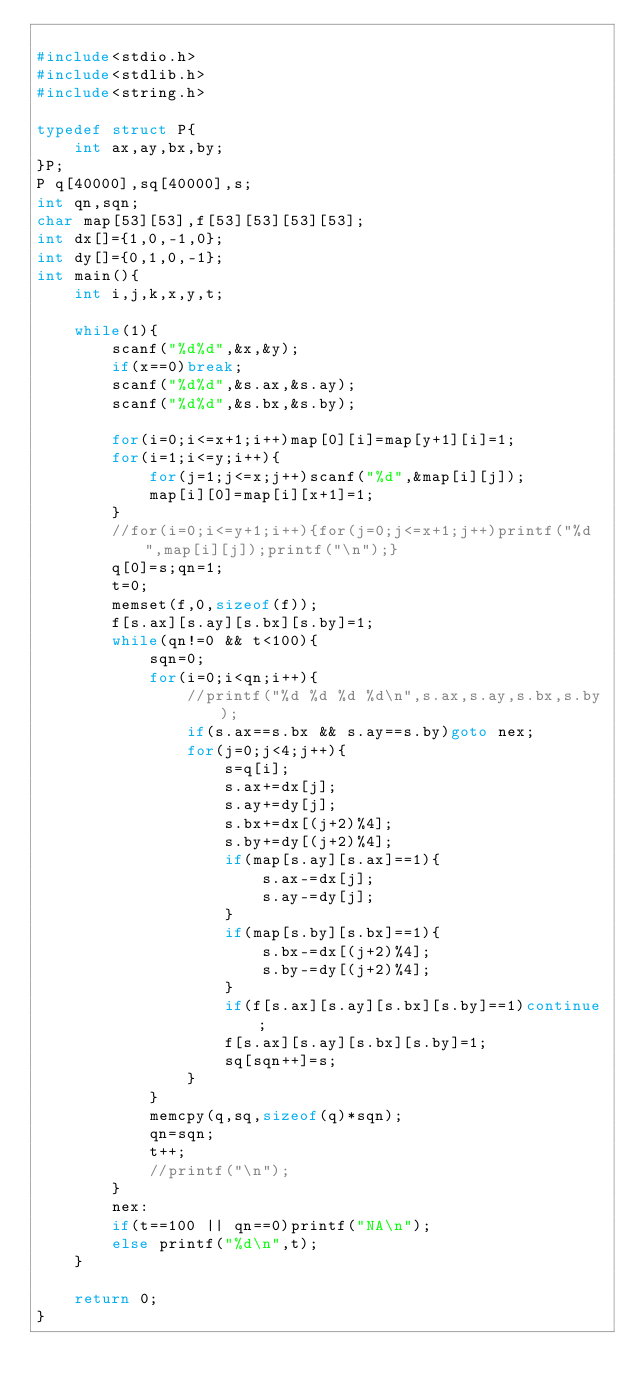Convert code to text. <code><loc_0><loc_0><loc_500><loc_500><_C_>
#include<stdio.h>
#include<stdlib.h>
#include<string.h>

typedef struct P{
	int ax,ay,bx,by;
}P;
P q[40000],sq[40000],s;
int qn,sqn;
char map[53][53],f[53][53][53][53];
int dx[]={1,0,-1,0};
int dy[]={0,1,0,-1};
int main(){
	int i,j,k,x,y,t;
	
	while(1){
		scanf("%d%d",&x,&y);
		if(x==0)break;
		scanf("%d%d",&s.ax,&s.ay);
		scanf("%d%d",&s.bx,&s.by);
		
		for(i=0;i<=x+1;i++)map[0][i]=map[y+1][i]=1;
		for(i=1;i<=y;i++){
			for(j=1;j<=x;j++)scanf("%d",&map[i][j]);
			map[i][0]=map[i][x+1]=1;
		}
		//for(i=0;i<=y+1;i++){for(j=0;j<=x+1;j++)printf("%d",map[i][j]);printf("\n");}
		q[0]=s;qn=1;
		t=0;
		memset(f,0,sizeof(f));
		f[s.ax][s.ay][s.bx][s.by]=1;
		while(qn!=0 && t<100){
			sqn=0;
			for(i=0;i<qn;i++){
				//printf("%d %d %d %d\n",s.ax,s.ay,s.bx,s.by);
				if(s.ax==s.bx && s.ay==s.by)goto nex;
				for(j=0;j<4;j++){
					s=q[i];
					s.ax+=dx[j];
					s.ay+=dy[j];
					s.bx+=dx[(j+2)%4];
					s.by+=dy[(j+2)%4];
					if(map[s.ay][s.ax]==1){
						s.ax-=dx[j];
						s.ay-=dy[j];
					}
					if(map[s.by][s.bx]==1){
						s.bx-=dx[(j+2)%4];
						s.by-=dy[(j+2)%4];
					}
					if(f[s.ax][s.ay][s.bx][s.by]==1)continue;
					f[s.ax][s.ay][s.bx][s.by]=1;
					sq[sqn++]=s;
				}
			}
			memcpy(q,sq,sizeof(q)*sqn);
			qn=sqn;
			t++;
			//printf("\n");
		}
		nex:
		if(t==100 || qn==0)printf("NA\n");
		else printf("%d\n",t);
	}
	
	return 0;
}</code> 